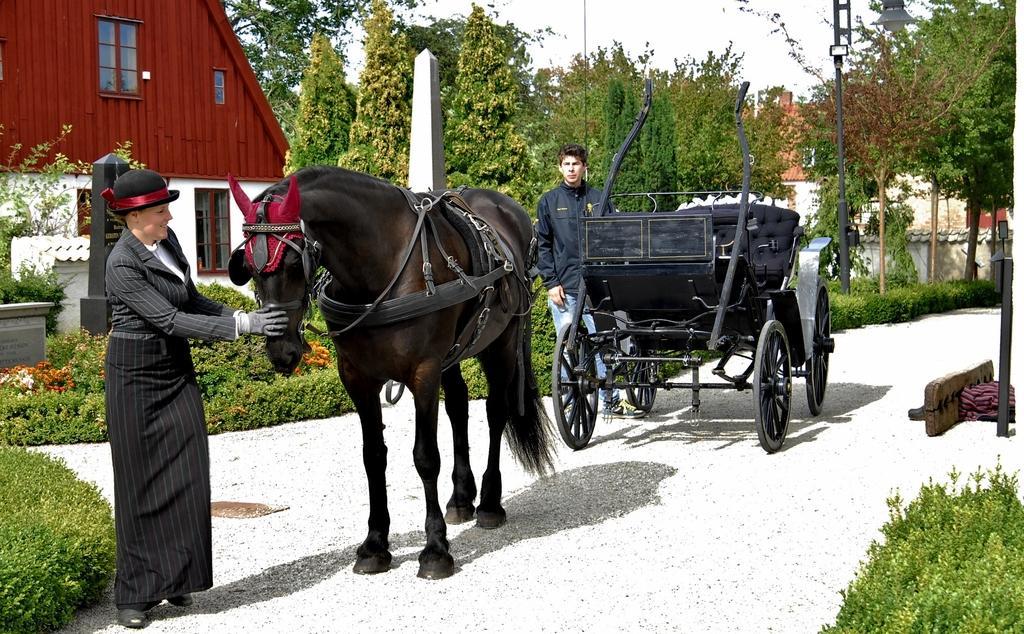How would you summarize this image in a sentence or two? In this picture there are two people and a horse the lady is holding the horse and the floor is white in colour. In the background there is a beautiful red house with windows and trees all over the place. There is a light lamp pole located and a horse cart in the picture 